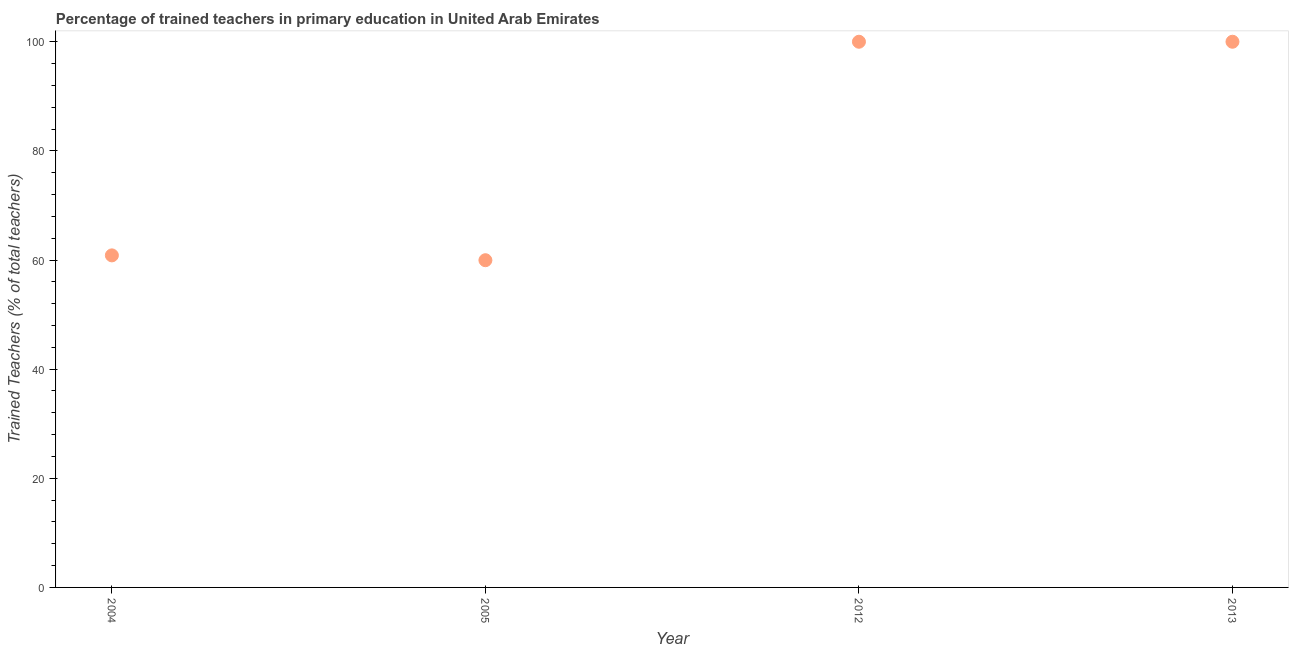What is the percentage of trained teachers in 2005?
Give a very brief answer. 59.97. Across all years, what is the minimum percentage of trained teachers?
Your answer should be very brief. 59.97. What is the sum of the percentage of trained teachers?
Make the answer very short. 320.82. What is the difference between the percentage of trained teachers in 2004 and 2005?
Your answer should be compact. 0.89. What is the average percentage of trained teachers per year?
Ensure brevity in your answer.  80.2. What is the median percentage of trained teachers?
Your response must be concise. 80.43. In how many years, is the percentage of trained teachers greater than 76 %?
Provide a succinct answer. 2. Do a majority of the years between 2005 and 2004 (inclusive) have percentage of trained teachers greater than 36 %?
Keep it short and to the point. No. What is the ratio of the percentage of trained teachers in 2005 to that in 2013?
Provide a succinct answer. 0.6. Is the percentage of trained teachers in 2005 less than that in 2013?
Provide a succinct answer. Yes. Is the sum of the percentage of trained teachers in 2012 and 2013 greater than the maximum percentage of trained teachers across all years?
Your answer should be very brief. Yes. What is the difference between the highest and the lowest percentage of trained teachers?
Offer a terse response. 40.03. In how many years, is the percentage of trained teachers greater than the average percentage of trained teachers taken over all years?
Provide a succinct answer. 2. Does the percentage of trained teachers monotonically increase over the years?
Provide a succinct answer. No. Does the graph contain any zero values?
Your answer should be compact. No. Does the graph contain grids?
Ensure brevity in your answer.  No. What is the title of the graph?
Provide a short and direct response. Percentage of trained teachers in primary education in United Arab Emirates. What is the label or title of the Y-axis?
Provide a short and direct response. Trained Teachers (% of total teachers). What is the Trained Teachers (% of total teachers) in 2004?
Your response must be concise. 60.85. What is the Trained Teachers (% of total teachers) in 2005?
Ensure brevity in your answer.  59.97. What is the Trained Teachers (% of total teachers) in 2012?
Your answer should be compact. 100. What is the Trained Teachers (% of total teachers) in 2013?
Your answer should be very brief. 100. What is the difference between the Trained Teachers (% of total teachers) in 2004 and 2005?
Give a very brief answer. 0.89. What is the difference between the Trained Teachers (% of total teachers) in 2004 and 2012?
Give a very brief answer. -39.15. What is the difference between the Trained Teachers (% of total teachers) in 2004 and 2013?
Ensure brevity in your answer.  -39.15. What is the difference between the Trained Teachers (% of total teachers) in 2005 and 2012?
Offer a very short reply. -40.03. What is the difference between the Trained Teachers (% of total teachers) in 2005 and 2013?
Give a very brief answer. -40.03. What is the difference between the Trained Teachers (% of total teachers) in 2012 and 2013?
Keep it short and to the point. 0. What is the ratio of the Trained Teachers (% of total teachers) in 2004 to that in 2012?
Keep it short and to the point. 0.61. What is the ratio of the Trained Teachers (% of total teachers) in 2004 to that in 2013?
Keep it short and to the point. 0.61. What is the ratio of the Trained Teachers (% of total teachers) in 2005 to that in 2012?
Keep it short and to the point. 0.6. What is the ratio of the Trained Teachers (% of total teachers) in 2012 to that in 2013?
Make the answer very short. 1. 